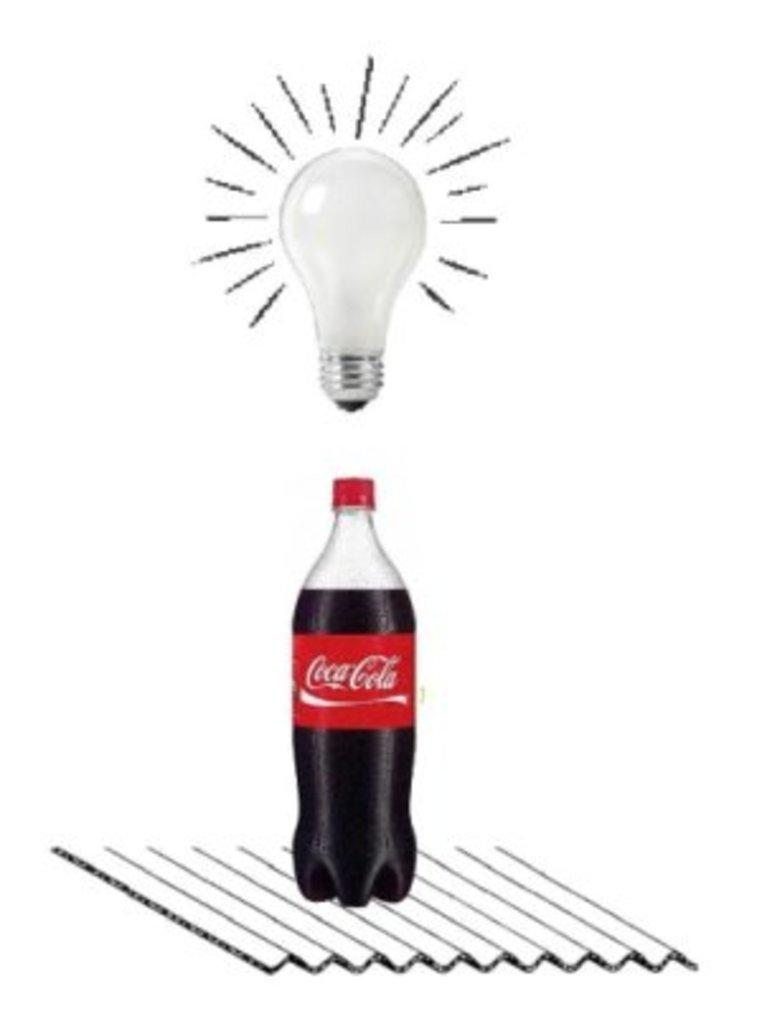What type of drink bottle is in the image? There is a cool drink bottle in the image. What brand is the drink bottle? The bottle has a 'Coca Cola' sticker on it. What color is the lid on the bottle? There is a red color lid above the bottle. What type of lighting is visible in the image? There is a white bulb visible in the image. How does the doll help the person in the image? There is no doll present in the image, so it cannot help anyone in the image. 